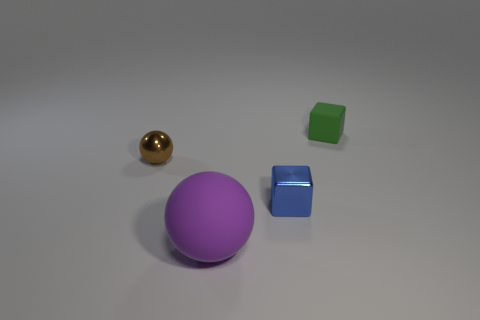Are the large object and the small cube that is behind the blue object made of the same material?
Your answer should be compact. Yes. What is the shape of the small thing that is to the right of the tiny block in front of the green cube?
Make the answer very short. Cube. There is a shiny cube; does it have the same color as the tiny thing that is behind the brown object?
Provide a short and direct response. No. Is there any other thing that has the same material as the purple object?
Your answer should be very brief. Yes. The brown metal object has what shape?
Give a very brief answer. Sphere. There is a cube left of the tiny block that is behind the tiny brown shiny thing; what size is it?
Your answer should be compact. Small. Is the number of small blue metallic objects to the left of the purple thing the same as the number of big purple balls that are behind the blue metal block?
Keep it short and to the point. Yes. What is the material of the small object that is both on the right side of the big matte object and on the left side of the matte cube?
Ensure brevity in your answer.  Metal. There is a shiny cube; is its size the same as the rubber thing in front of the green block?
Make the answer very short. No. What number of other things are the same color as the metallic block?
Provide a short and direct response. 0. 